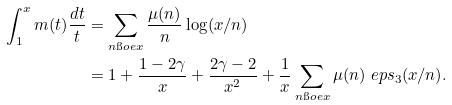Convert formula to latex. <formula><loc_0><loc_0><loc_500><loc_500>\int _ { 1 } ^ { x } m ( t ) \frac { d t } { t } & = \sum _ { n \i o e x } \frac { \mu ( n ) } { n } \log ( x / n ) \\ & = 1 + \frac { 1 - 2 \gamma } { x } + \frac { 2 \gamma - 2 } { x ^ { 2 } } + \frac { 1 } { x } \sum _ { n \i o e x } \mu ( n ) \ e p s _ { 3 } ( x / n ) .</formula> 